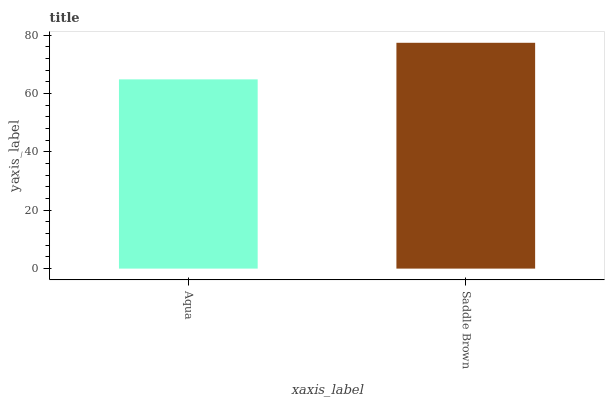Is Aqua the minimum?
Answer yes or no. Yes. Is Saddle Brown the maximum?
Answer yes or no. Yes. Is Saddle Brown the minimum?
Answer yes or no. No. Is Saddle Brown greater than Aqua?
Answer yes or no. Yes. Is Aqua less than Saddle Brown?
Answer yes or no. Yes. Is Aqua greater than Saddle Brown?
Answer yes or no. No. Is Saddle Brown less than Aqua?
Answer yes or no. No. Is Saddle Brown the high median?
Answer yes or no. Yes. Is Aqua the low median?
Answer yes or no. Yes. Is Aqua the high median?
Answer yes or no. No. Is Saddle Brown the low median?
Answer yes or no. No. 